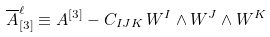<formula> <loc_0><loc_0><loc_500><loc_500>\overline { A } ^ { \ell } _ { [ 3 ] } \equiv A ^ { [ 3 ] } - C _ { I J K } \, W ^ { I } \wedge W ^ { J } \wedge W ^ { K }</formula> 